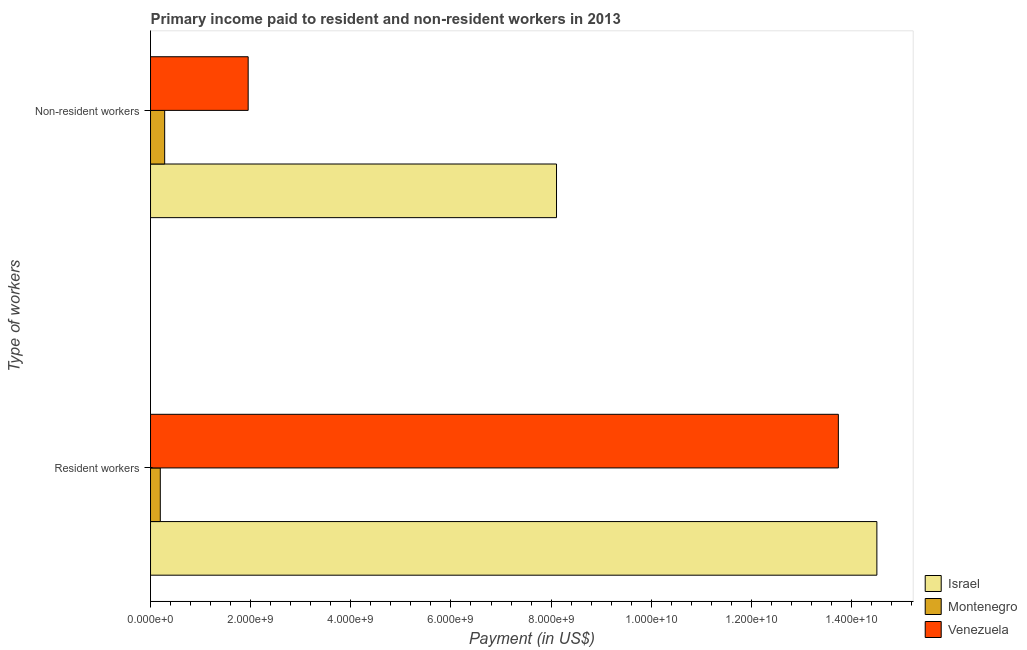How many different coloured bars are there?
Your answer should be compact. 3. How many groups of bars are there?
Provide a succinct answer. 2. Are the number of bars on each tick of the Y-axis equal?
Provide a succinct answer. Yes. How many bars are there on the 2nd tick from the bottom?
Provide a short and direct response. 3. What is the label of the 1st group of bars from the top?
Ensure brevity in your answer.  Non-resident workers. What is the payment made to non-resident workers in Venezuela?
Provide a short and direct response. 1.95e+09. Across all countries, what is the maximum payment made to non-resident workers?
Provide a short and direct response. 8.11e+09. Across all countries, what is the minimum payment made to resident workers?
Offer a very short reply. 1.95e+08. In which country was the payment made to non-resident workers minimum?
Your response must be concise. Montenegro. What is the total payment made to non-resident workers in the graph?
Offer a very short reply. 1.03e+1. What is the difference between the payment made to non-resident workers in Montenegro and that in Venezuela?
Keep it short and to the point. -1.67e+09. What is the difference between the payment made to non-resident workers in Venezuela and the payment made to resident workers in Montenegro?
Keep it short and to the point. 1.76e+09. What is the average payment made to non-resident workers per country?
Give a very brief answer. 3.45e+09. What is the difference between the payment made to resident workers and payment made to non-resident workers in Montenegro?
Give a very brief answer. -8.74e+07. In how many countries, is the payment made to non-resident workers greater than 11200000000 US$?
Your answer should be very brief. 0. What is the ratio of the payment made to non-resident workers in Israel to that in Venezuela?
Offer a very short reply. 4.16. Is the payment made to resident workers in Montenegro less than that in Venezuela?
Provide a short and direct response. Yes. In how many countries, is the payment made to resident workers greater than the average payment made to resident workers taken over all countries?
Your answer should be compact. 2. What does the 2nd bar from the top in Resident workers represents?
Give a very brief answer. Montenegro. What does the 1st bar from the bottom in Non-resident workers represents?
Provide a short and direct response. Israel. Are all the bars in the graph horizontal?
Your answer should be very brief. Yes. Does the graph contain any zero values?
Provide a short and direct response. No. How many legend labels are there?
Ensure brevity in your answer.  3. How are the legend labels stacked?
Give a very brief answer. Vertical. What is the title of the graph?
Your response must be concise. Primary income paid to resident and non-resident workers in 2013. Does "Niger" appear as one of the legend labels in the graph?
Your answer should be compact. No. What is the label or title of the X-axis?
Provide a short and direct response. Payment (in US$). What is the label or title of the Y-axis?
Your answer should be very brief. Type of workers. What is the Payment (in US$) of Israel in Resident workers?
Your answer should be very brief. 1.45e+1. What is the Payment (in US$) of Montenegro in Resident workers?
Your answer should be very brief. 1.95e+08. What is the Payment (in US$) of Venezuela in Resident workers?
Give a very brief answer. 1.37e+1. What is the Payment (in US$) in Israel in Non-resident workers?
Offer a terse response. 8.11e+09. What is the Payment (in US$) of Montenegro in Non-resident workers?
Keep it short and to the point. 2.82e+08. What is the Payment (in US$) in Venezuela in Non-resident workers?
Ensure brevity in your answer.  1.95e+09. Across all Type of workers, what is the maximum Payment (in US$) of Israel?
Provide a short and direct response. 1.45e+1. Across all Type of workers, what is the maximum Payment (in US$) in Montenegro?
Make the answer very short. 2.82e+08. Across all Type of workers, what is the maximum Payment (in US$) of Venezuela?
Offer a very short reply. 1.37e+1. Across all Type of workers, what is the minimum Payment (in US$) in Israel?
Provide a short and direct response. 8.11e+09. Across all Type of workers, what is the minimum Payment (in US$) of Montenegro?
Keep it short and to the point. 1.95e+08. Across all Type of workers, what is the minimum Payment (in US$) in Venezuela?
Your answer should be very brief. 1.95e+09. What is the total Payment (in US$) in Israel in the graph?
Offer a terse response. 2.26e+1. What is the total Payment (in US$) in Montenegro in the graph?
Provide a succinct answer. 4.77e+08. What is the total Payment (in US$) in Venezuela in the graph?
Keep it short and to the point. 1.57e+1. What is the difference between the Payment (in US$) of Israel in Resident workers and that in Non-resident workers?
Provide a succinct answer. 6.40e+09. What is the difference between the Payment (in US$) of Montenegro in Resident workers and that in Non-resident workers?
Keep it short and to the point. -8.74e+07. What is the difference between the Payment (in US$) of Venezuela in Resident workers and that in Non-resident workers?
Keep it short and to the point. 1.18e+1. What is the difference between the Payment (in US$) in Israel in Resident workers and the Payment (in US$) in Montenegro in Non-resident workers?
Your answer should be compact. 1.42e+1. What is the difference between the Payment (in US$) of Israel in Resident workers and the Payment (in US$) of Venezuela in Non-resident workers?
Offer a very short reply. 1.26e+1. What is the difference between the Payment (in US$) in Montenegro in Resident workers and the Payment (in US$) in Venezuela in Non-resident workers?
Keep it short and to the point. -1.76e+09. What is the average Payment (in US$) of Israel per Type of workers?
Your answer should be very brief. 1.13e+1. What is the average Payment (in US$) of Montenegro per Type of workers?
Your answer should be compact. 2.39e+08. What is the average Payment (in US$) in Venezuela per Type of workers?
Give a very brief answer. 7.84e+09. What is the difference between the Payment (in US$) in Israel and Payment (in US$) in Montenegro in Resident workers?
Make the answer very short. 1.43e+1. What is the difference between the Payment (in US$) of Israel and Payment (in US$) of Venezuela in Resident workers?
Make the answer very short. 7.69e+08. What is the difference between the Payment (in US$) in Montenegro and Payment (in US$) in Venezuela in Resident workers?
Give a very brief answer. -1.35e+1. What is the difference between the Payment (in US$) of Israel and Payment (in US$) of Montenegro in Non-resident workers?
Keep it short and to the point. 7.83e+09. What is the difference between the Payment (in US$) in Israel and Payment (in US$) in Venezuela in Non-resident workers?
Provide a succinct answer. 6.16e+09. What is the difference between the Payment (in US$) in Montenegro and Payment (in US$) in Venezuela in Non-resident workers?
Keep it short and to the point. -1.67e+09. What is the ratio of the Payment (in US$) in Israel in Resident workers to that in Non-resident workers?
Make the answer very short. 1.79. What is the ratio of the Payment (in US$) in Montenegro in Resident workers to that in Non-resident workers?
Ensure brevity in your answer.  0.69. What is the ratio of the Payment (in US$) of Venezuela in Resident workers to that in Non-resident workers?
Make the answer very short. 7.05. What is the difference between the highest and the second highest Payment (in US$) of Israel?
Provide a succinct answer. 6.40e+09. What is the difference between the highest and the second highest Payment (in US$) in Montenegro?
Your answer should be very brief. 8.74e+07. What is the difference between the highest and the second highest Payment (in US$) in Venezuela?
Make the answer very short. 1.18e+1. What is the difference between the highest and the lowest Payment (in US$) in Israel?
Your answer should be very brief. 6.40e+09. What is the difference between the highest and the lowest Payment (in US$) of Montenegro?
Your response must be concise. 8.74e+07. What is the difference between the highest and the lowest Payment (in US$) of Venezuela?
Give a very brief answer. 1.18e+1. 